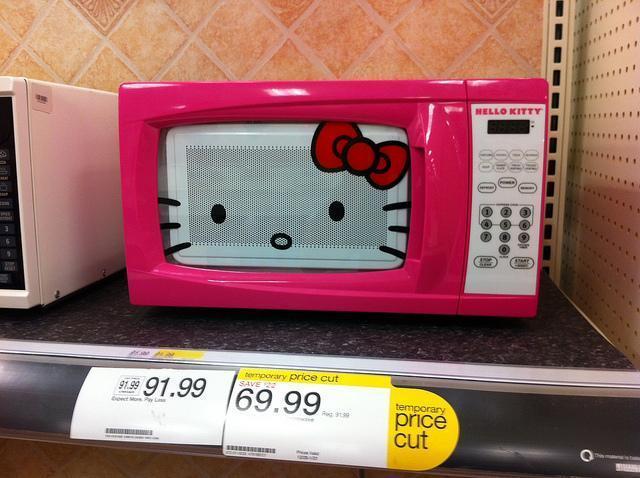How many microwaves are in the picture?
Give a very brief answer. 2. 